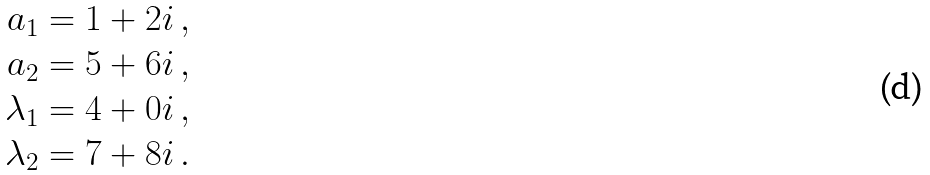<formula> <loc_0><loc_0><loc_500><loc_500>a _ { 1 } & = 1 + 2 i \, , \\ a _ { 2 } & = 5 + 6 i \, , \\ \lambda _ { 1 } & = 4 + 0 i \, , \\ \lambda _ { 2 } & = 7 + 8 i \, .</formula> 